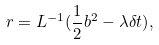Convert formula to latex. <formula><loc_0><loc_0><loc_500><loc_500>r = L ^ { - 1 } ( { \frac { 1 } { 2 } b ^ { 2 } - \lambda \delta t ) } ,</formula> 